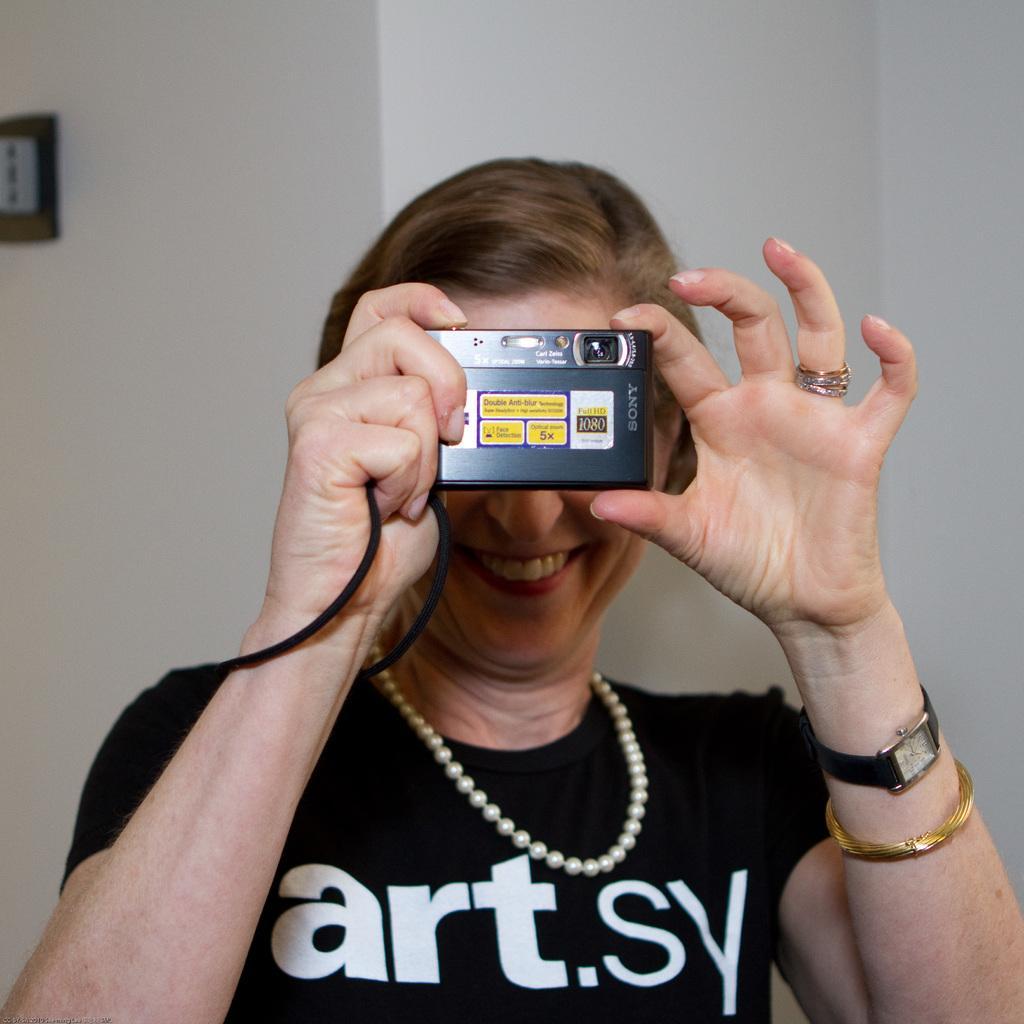Describe this image in one or two sentences. In this image we can see a woman holding a camera. On the backside we can see a frame on a wall. 